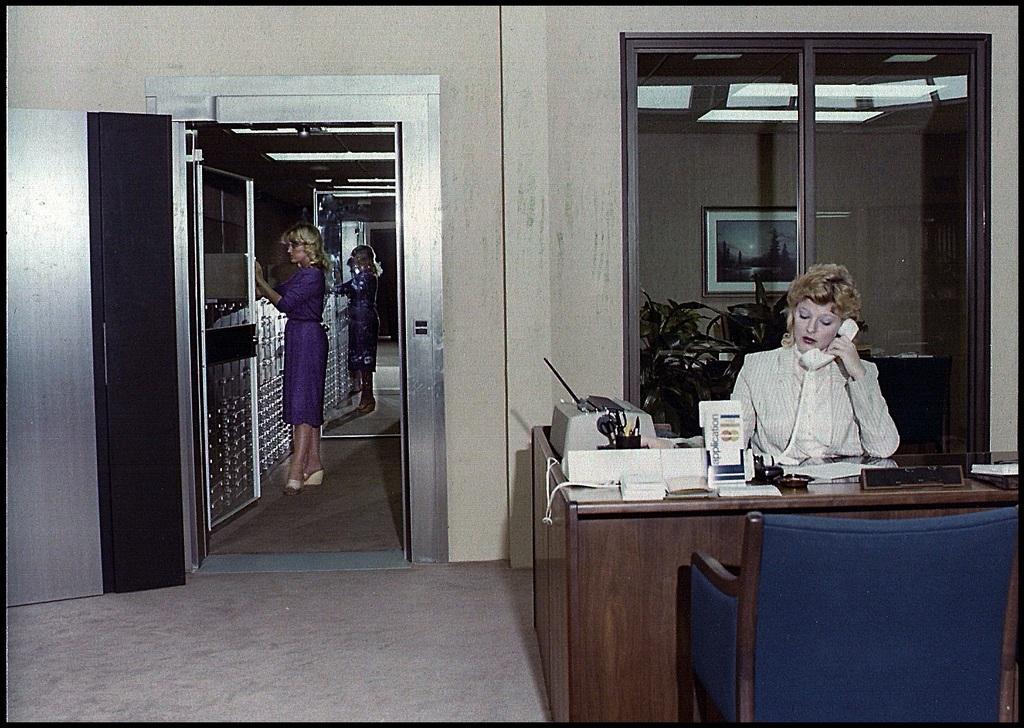Can you describe this image briefly? The person wearing a white coat is sitting and talking in a phone and there is table and chair in front of her and the other person wearing violet dress is doing something in the room and there is a mirror beside her. 